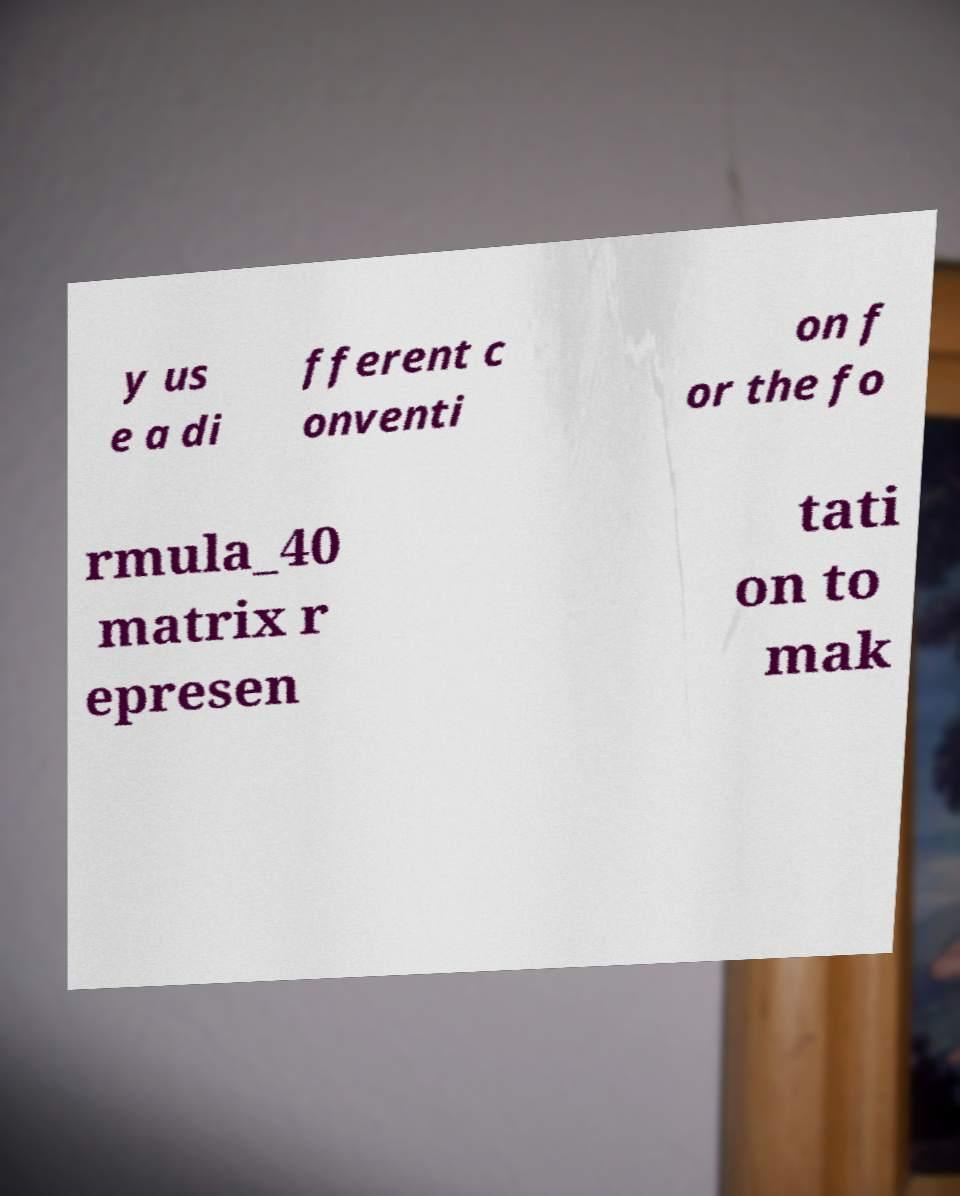There's text embedded in this image that I need extracted. Can you transcribe it verbatim? y us e a di fferent c onventi on f or the fo rmula_40 matrix r epresen tati on to mak 